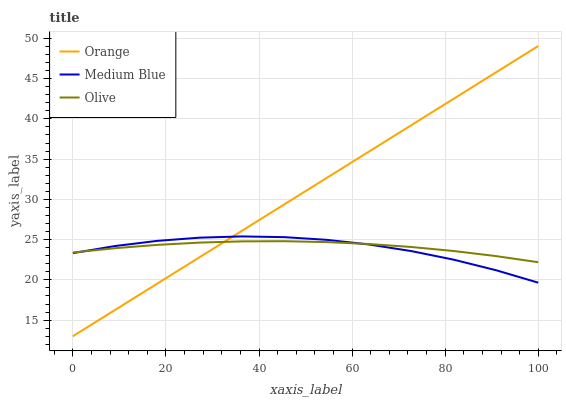Does Medium Blue have the minimum area under the curve?
Answer yes or no. Yes. Does Orange have the maximum area under the curve?
Answer yes or no. Yes. Does Olive have the minimum area under the curve?
Answer yes or no. No. Does Olive have the maximum area under the curve?
Answer yes or no. No. Is Orange the smoothest?
Answer yes or no. Yes. Is Medium Blue the roughest?
Answer yes or no. Yes. Is Olive the smoothest?
Answer yes or no. No. Is Olive the roughest?
Answer yes or no. No. Does Orange have the lowest value?
Answer yes or no. Yes. Does Medium Blue have the lowest value?
Answer yes or no. No. Does Orange have the highest value?
Answer yes or no. Yes. Does Medium Blue have the highest value?
Answer yes or no. No. Does Medium Blue intersect Olive?
Answer yes or no. Yes. Is Medium Blue less than Olive?
Answer yes or no. No. Is Medium Blue greater than Olive?
Answer yes or no. No. 